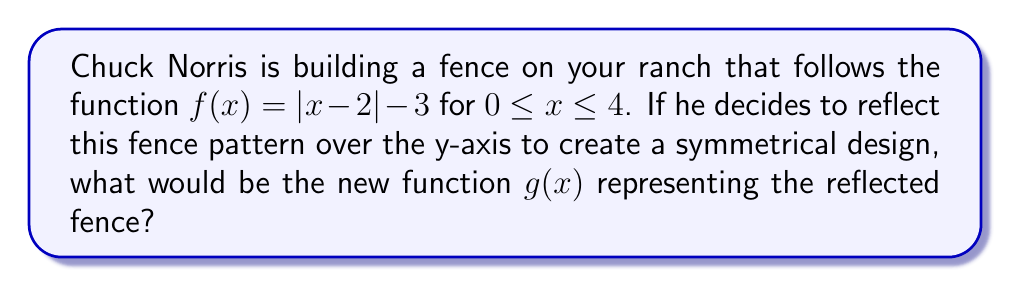Teach me how to tackle this problem. To reflect a function over the y-axis, we replace every x with -x in the original function. Let's follow these steps:

1. Start with the original function: $f(x)=|x-2|-3$

2. Replace every x with -x:
   $g(x) = |(-x)-2|-3$

3. Simplify the expression inside the absolute value brackets:
   $g(x) = |-x-2|-3$

4. Factor out the negative sign:
   $g(x) = |-1(x+2)|-3$

5. The negative sign can be moved outside the absolute value brackets:
   $g(x) = |-1||(x+2)|-3$

6. Simplify, as |-1| = 1:
   $g(x) = |x+2|-3$

This is the final form of the reflected function.
Answer: $g(x) = |x+2|-3$ 